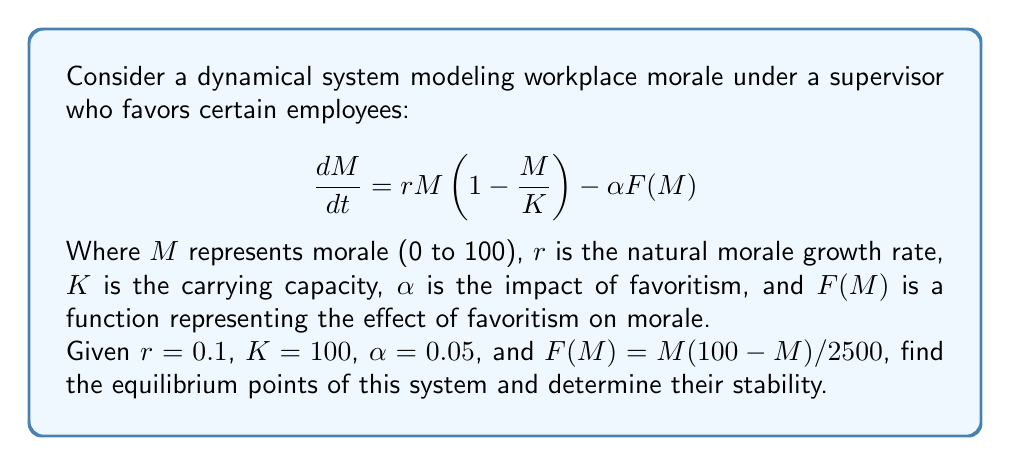Solve this math problem. To solve this problem, we'll follow these steps:

1) Find the equilibrium points by setting $\frac{dM}{dt} = 0$:

   $$0 = rM(1-\frac{M}{K}) - \alpha F(M)$$
   $$0 = 0.1M(1-\frac{M}{100}) - 0.05\frac{M(100-M)}{2500}$$

2) Simplify the equation:

   $$0 = 0.1M - 0.001M^2 - 0.002M + 0.00002M^2$$
   $$0 = 0.098M - 0.00098M^2$$

3) Factor out M:

   $$M(0.098 - 0.00098M) = 0$$

4) Solve for M:

   $M = 0$ or $0.098 - 0.00098M = 0$
   
   $M = 0$ or $M = 100$

5) To determine stability, we need to find $\frac{d}{dM}(\frac{dM}{dt})$ and evaluate at each equilibrium point:

   $$\frac{d}{dM}(\frac{dM}{dt}) = r(1-\frac{2M}{K}) - \alpha F'(M)$$
   $$= 0.1(1-\frac{2M}{100}) - 0.05(\frac{100-2M}{2500})$$
   $$= 0.1 - 0.002M - 0.002 + 0.00004M$$
   $$= 0.098 - 0.00196M$$

6) Evaluate at M = 0:
   
   $0.098 - 0.00196(0) = 0.098 > 0$, so M = 0 is unstable.

7) Evaluate at M = 100:
   
   $0.098 - 0.00196(100) = -0.098 < 0$, so M = 100 is stable.
Answer: Equilibrium points: M = 0 (unstable) and M = 100 (stable). 